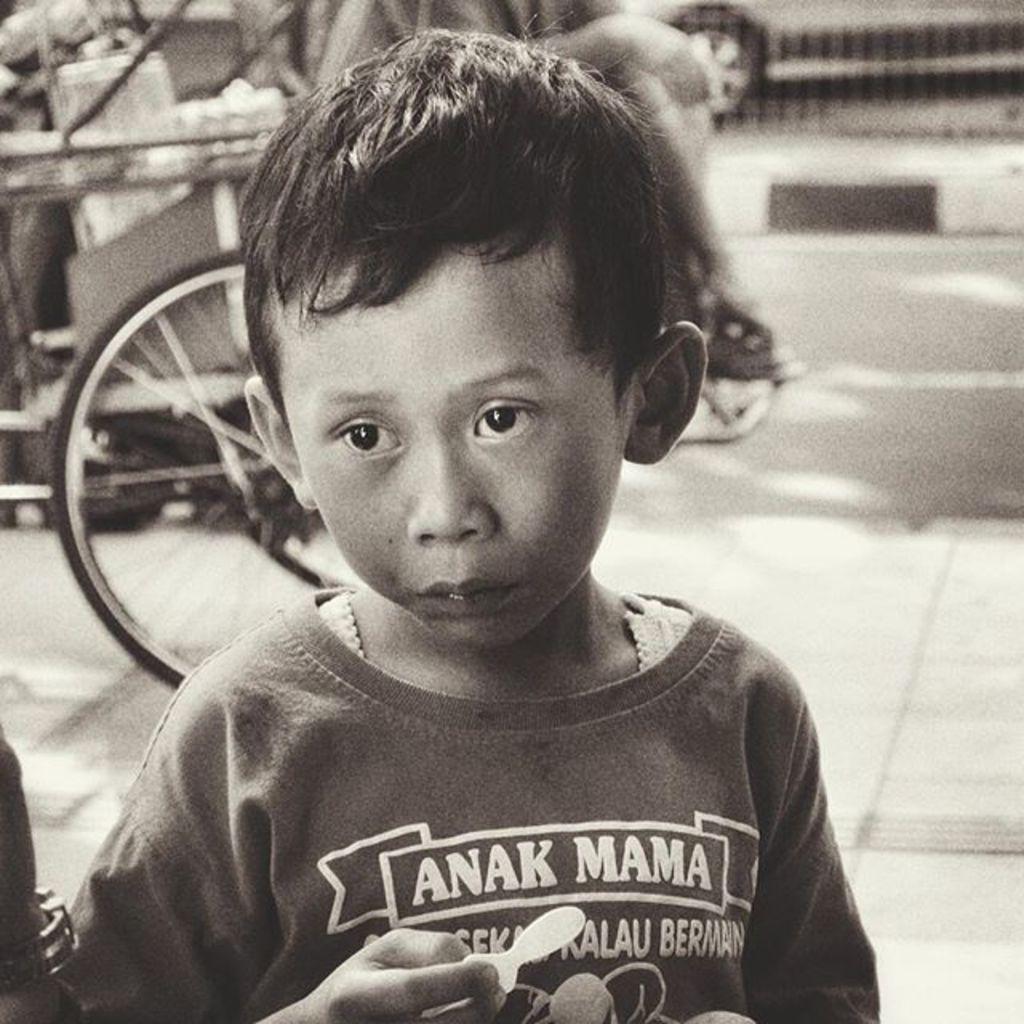Could you give a brief overview of what you see in this image? This is a black and white image. In this image we can see a boy holding something in the hand. In the background we can see a tire and some other items. And it is blurry in the background. 